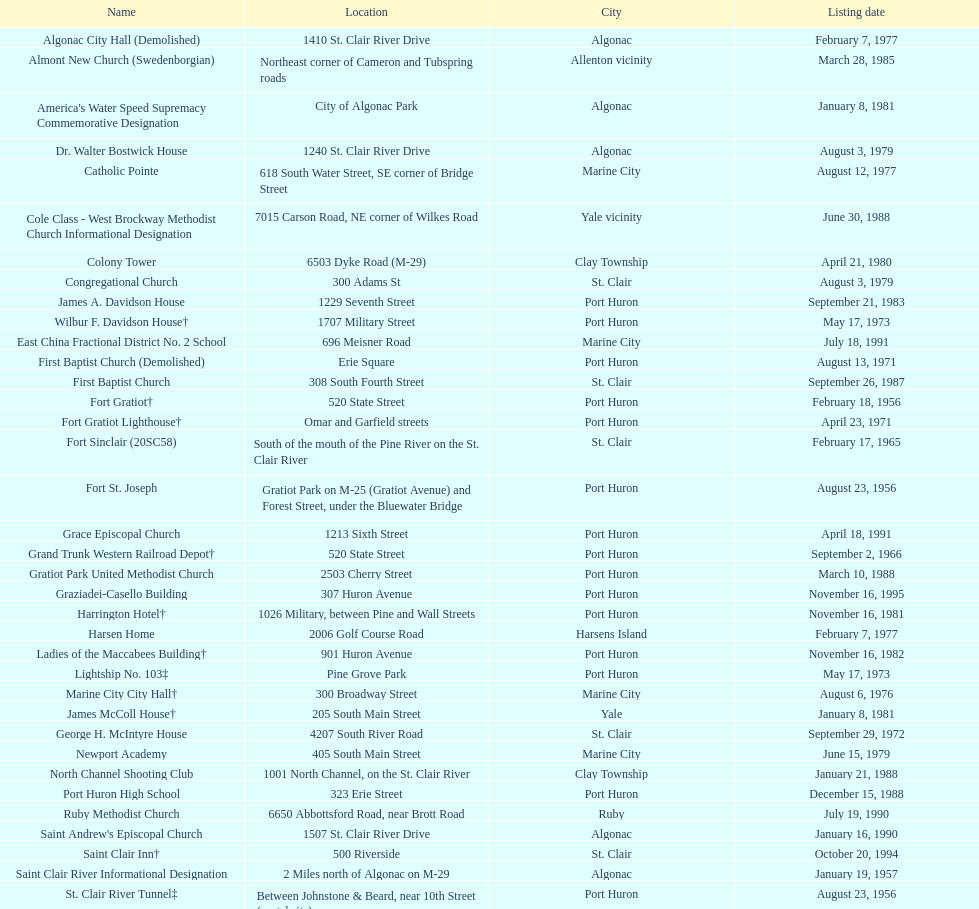In which urban area can the largest number of historical landmarks, intact or demolished, be found? Port Huron. 